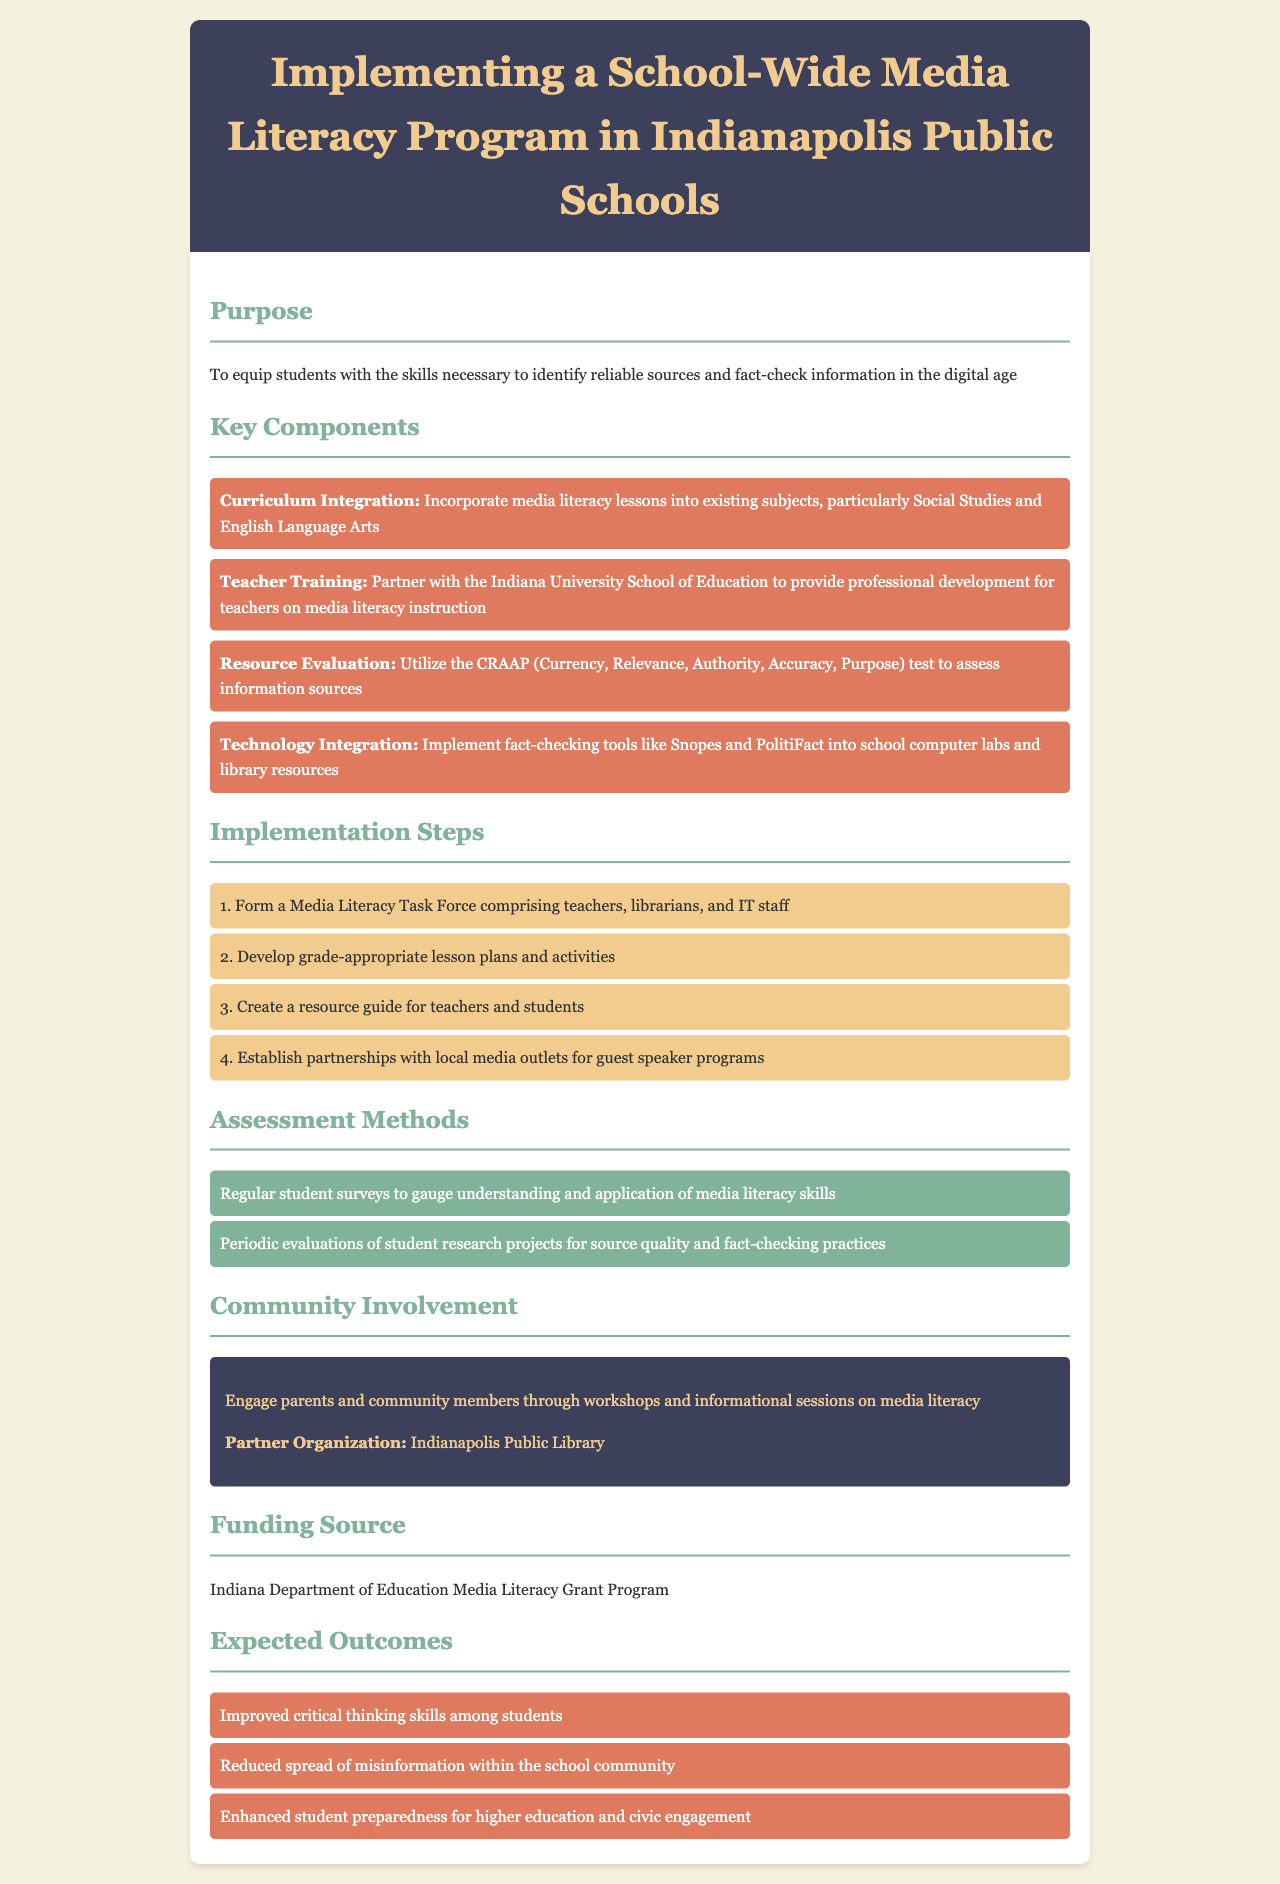What is the purpose of the media literacy program? The purpose of the program is to equip students with the skills necessary to identify reliable sources and fact-check information in the digital age.
Answer: equip students with the skills necessary to identify reliable sources and fact-check information in the digital age Which organization is partnered for teacher training? The policy document mentions a partnership with the Indiana University School of Education for teacher training.
Answer: Indiana University School of Education What is the funding source for the program? The program is funded by the Indiana Department of Education Media Literacy Grant Program.
Answer: Indiana Department of Education Media Literacy Grant Program How many implementation steps are listed? The document outlines four specific implementation steps necessary for the program's rollout.
Answer: 4 What is one expected outcome of the media literacy program? The document highlights improved critical thinking skills among students as one of the expected outcomes.
Answer: Improved critical thinking skills among students What evaluation method is used for assessing student understanding? Regular student surveys are utilized to gauge understanding and application of media literacy skills.
Answer: Regular student surveys What tool is suggested for technology integration? The policy suggests implementing fact-checking tools like Snopes and PolitiFact into school resources.
Answer: Snopes and PolitiFact What type of task force will be formed during implementation? A Media Literacy Task Force will be formed comprising teachers, librarians, and IT staff.
Answer: Media Literacy Task Force 